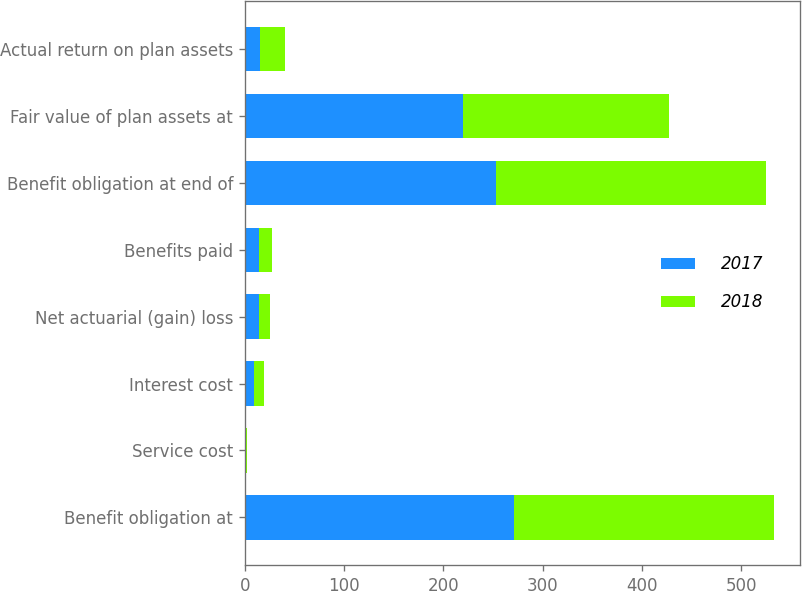<chart> <loc_0><loc_0><loc_500><loc_500><stacked_bar_chart><ecel><fcel>Benefit obligation at<fcel>Service cost<fcel>Interest cost<fcel>Net actuarial (gain) loss<fcel>Benefits paid<fcel>Benefit obligation at end of<fcel>Fair value of plan assets at<fcel>Actual return on plan assets<nl><fcel>2017<fcel>271.4<fcel>0.8<fcel>9.3<fcel>14.3<fcel>14<fcel>253.2<fcel>219.4<fcel>15.4<nl><fcel>2018<fcel>261.3<fcel>1.7<fcel>10<fcel>11.5<fcel>13.1<fcel>271.4<fcel>207.8<fcel>24.7<nl></chart> 